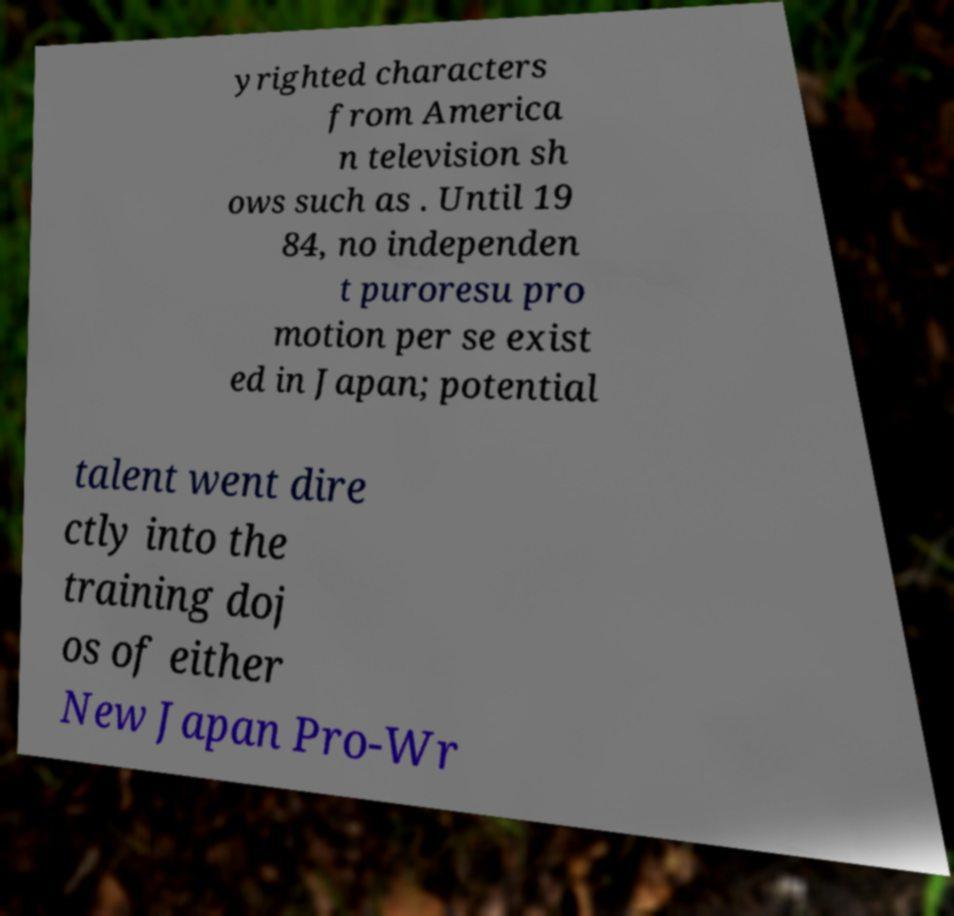What messages or text are displayed in this image? I need them in a readable, typed format. yrighted characters from America n television sh ows such as . Until 19 84, no independen t puroresu pro motion per se exist ed in Japan; potential talent went dire ctly into the training doj os of either New Japan Pro-Wr 